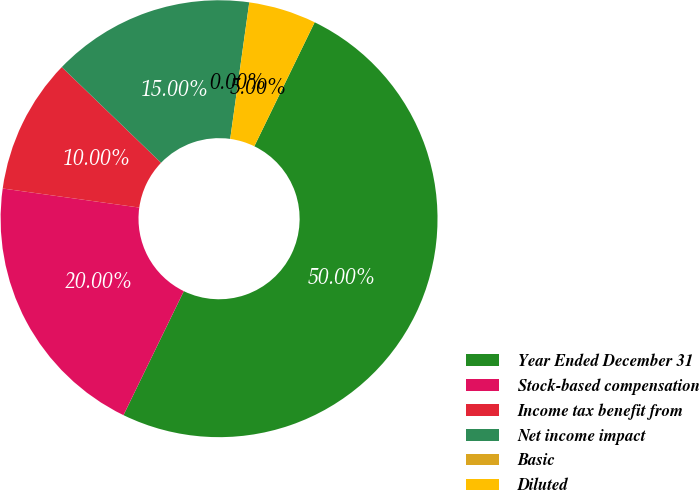Convert chart. <chart><loc_0><loc_0><loc_500><loc_500><pie_chart><fcel>Year Ended December 31<fcel>Stock-based compensation<fcel>Income tax benefit from<fcel>Net income impact<fcel>Basic<fcel>Diluted<nl><fcel>50.0%<fcel>20.0%<fcel>10.0%<fcel>15.0%<fcel>0.0%<fcel>5.0%<nl></chart> 